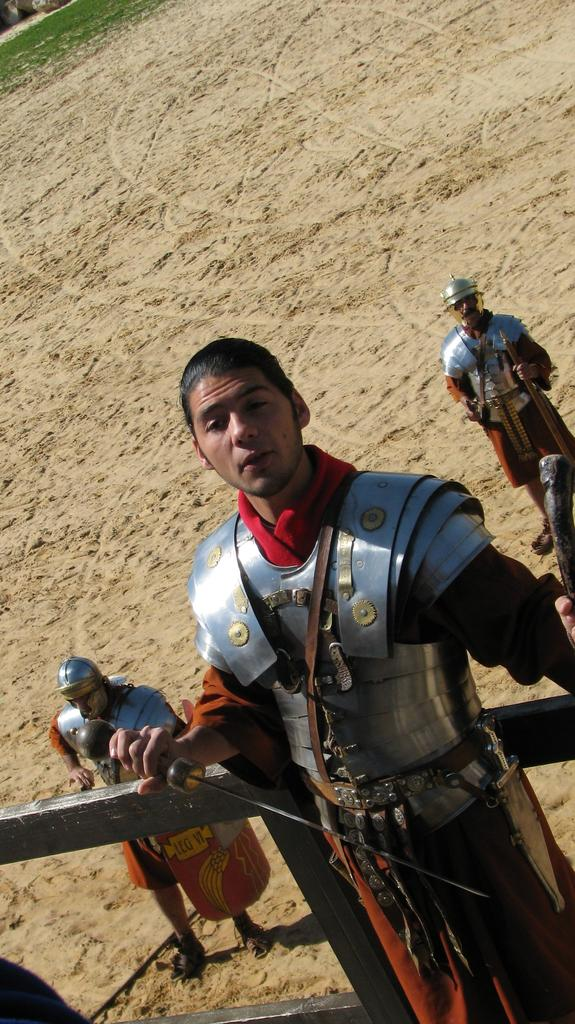How many people are in the image? There are three people in the image. What are the people doing in the image? The people are standing and holding swords. What type of clothing are the people wearing? They are wearing what appears to be a warrior suit. What type of terrain is visible in the image? There is sand visible. Can you tell me how many friends the person in the middle has in the image? There is no information about friends in the image, as it only shows three people standing and holding swords. Is there a chair visible in the image? No, there is no chair present in the image. 